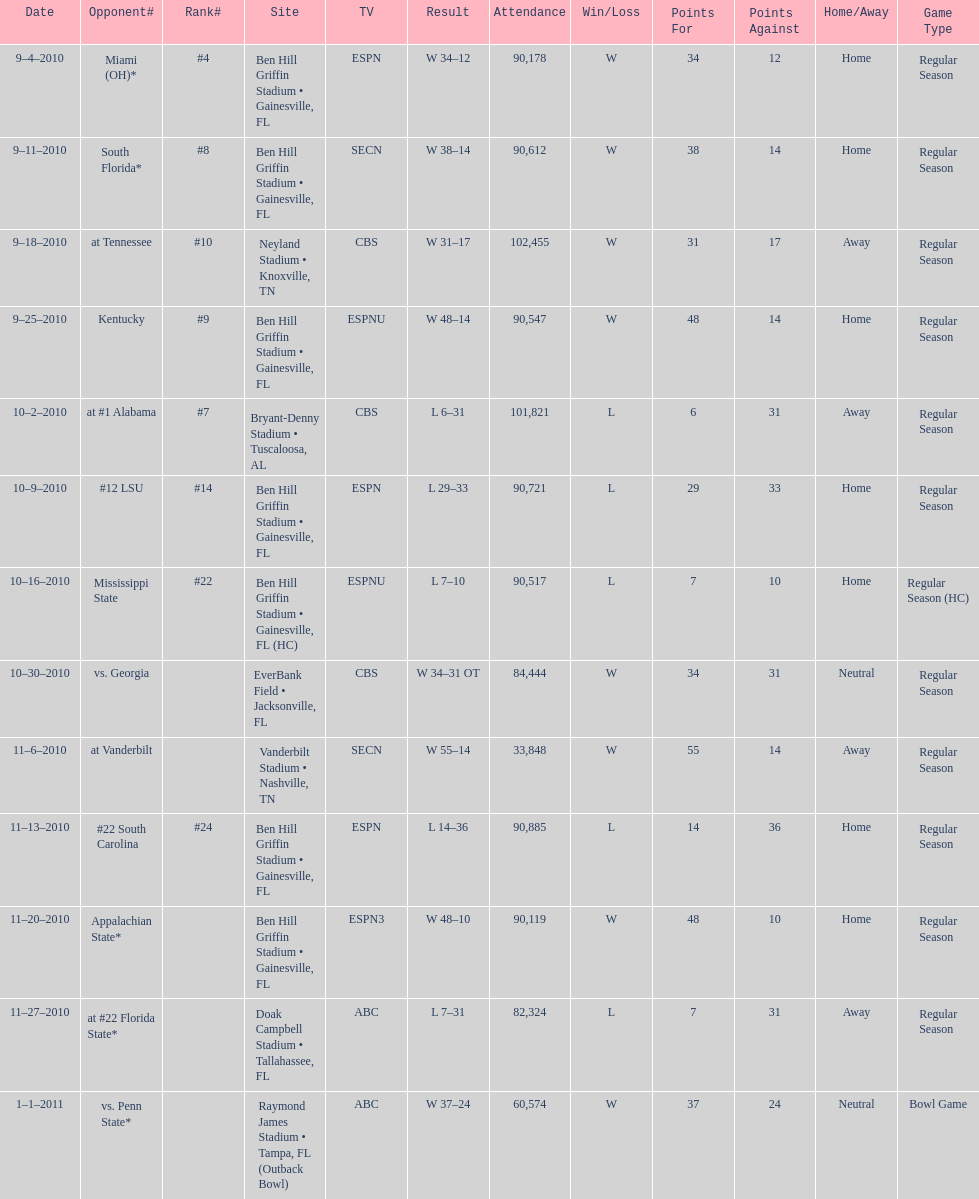How many games did the university of florida win by at least 10 points? 7. 